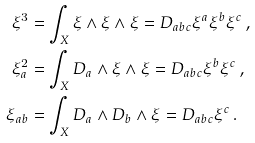Convert formula to latex. <formula><loc_0><loc_0><loc_500><loc_500>\xi ^ { 3 } & = \int _ { X } \xi \wedge \xi \wedge \xi = D _ { a b c } \xi ^ { a } \xi ^ { b } \xi ^ { c } \, , \\ \xi _ { a } ^ { 2 } & = \int _ { X } D _ { a } \wedge \xi \wedge \xi = D _ { a b c } \xi ^ { b } \xi ^ { c } \, , \\ \xi _ { a b } & = \int _ { X } D _ { a } \wedge D _ { b } \wedge \xi = D _ { a b c } \xi ^ { c } \, .</formula> 